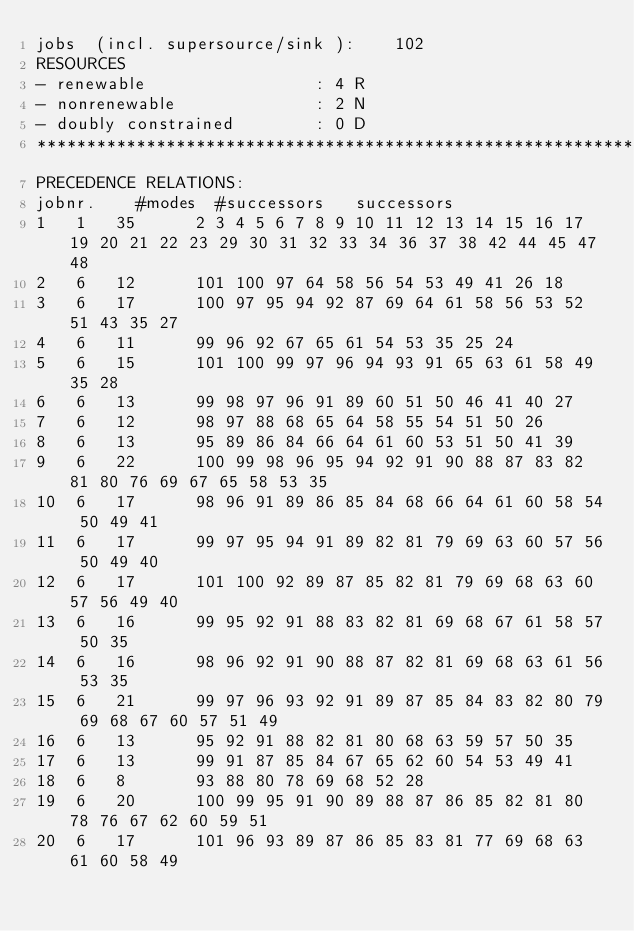Convert code to text. <code><loc_0><loc_0><loc_500><loc_500><_ObjectiveC_>jobs  (incl. supersource/sink ):	102
RESOURCES
- renewable                 : 4 R
- nonrenewable              : 2 N
- doubly constrained        : 0 D
************************************************************************
PRECEDENCE RELATIONS:
jobnr.    #modes  #successors   successors
1	1	35		2 3 4 5 6 7 8 9 10 11 12 13 14 15 16 17 19 20 21 22 23 29 30 31 32 33 34 36 37 38 42 44 45 47 48 
2	6	12		101 100 97 64 58 56 54 53 49 41 26 18 
3	6	17		100 97 95 94 92 87 69 64 61 58 56 53 52 51 43 35 27 
4	6	11		99 96 92 67 65 61 54 53 35 25 24 
5	6	15		101 100 99 97 96 94 93 91 65 63 61 58 49 35 28 
6	6	13		99 98 97 96 91 89 60 51 50 46 41 40 27 
7	6	12		98 97 88 68 65 64 58 55 54 51 50 26 
8	6	13		95 89 86 84 66 64 61 60 53 51 50 41 39 
9	6	22		100 99 98 96 95 94 92 91 90 88 87 83 82 81 80 76 69 67 65 58 53 35 
10	6	17		98 96 91 89 86 85 84 68 66 64 61 60 58 54 50 49 41 
11	6	17		99 97 95 94 91 89 82 81 79 69 63 60 57 56 50 49 40 
12	6	17		101 100 92 89 87 85 82 81 79 69 68 63 60 57 56 49 40 
13	6	16		99 95 92 91 88 83 82 81 69 68 67 61 58 57 50 35 
14	6	16		98 96 92 91 90 88 87 82 81 69 68 63 61 56 53 35 
15	6	21		99 97 96 93 92 91 89 87 85 84 83 82 80 79 69 68 67 60 57 51 49 
16	6	13		95 92 91 88 82 81 80 68 63 59 57 50 35 
17	6	13		99 91 87 85 84 67 65 62 60 54 53 49 41 
18	6	8		93 88 80 78 69 68 52 28 
19	6	20		100 99 95 91 90 89 88 87 86 85 82 81 80 78 76 67 62 60 59 51 
20	6	17		101 96 93 89 87 86 85 83 81 77 69 68 63 61 60 58 49 </code> 